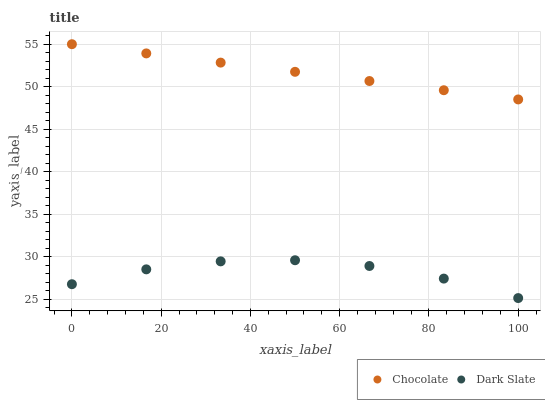Does Dark Slate have the minimum area under the curve?
Answer yes or no. Yes. Does Chocolate have the maximum area under the curve?
Answer yes or no. Yes. Does Chocolate have the minimum area under the curve?
Answer yes or no. No. Is Chocolate the smoothest?
Answer yes or no. Yes. Is Dark Slate the roughest?
Answer yes or no. Yes. Is Chocolate the roughest?
Answer yes or no. No. Does Dark Slate have the lowest value?
Answer yes or no. Yes. Does Chocolate have the lowest value?
Answer yes or no. No. Does Chocolate have the highest value?
Answer yes or no. Yes. Is Dark Slate less than Chocolate?
Answer yes or no. Yes. Is Chocolate greater than Dark Slate?
Answer yes or no. Yes. Does Dark Slate intersect Chocolate?
Answer yes or no. No. 